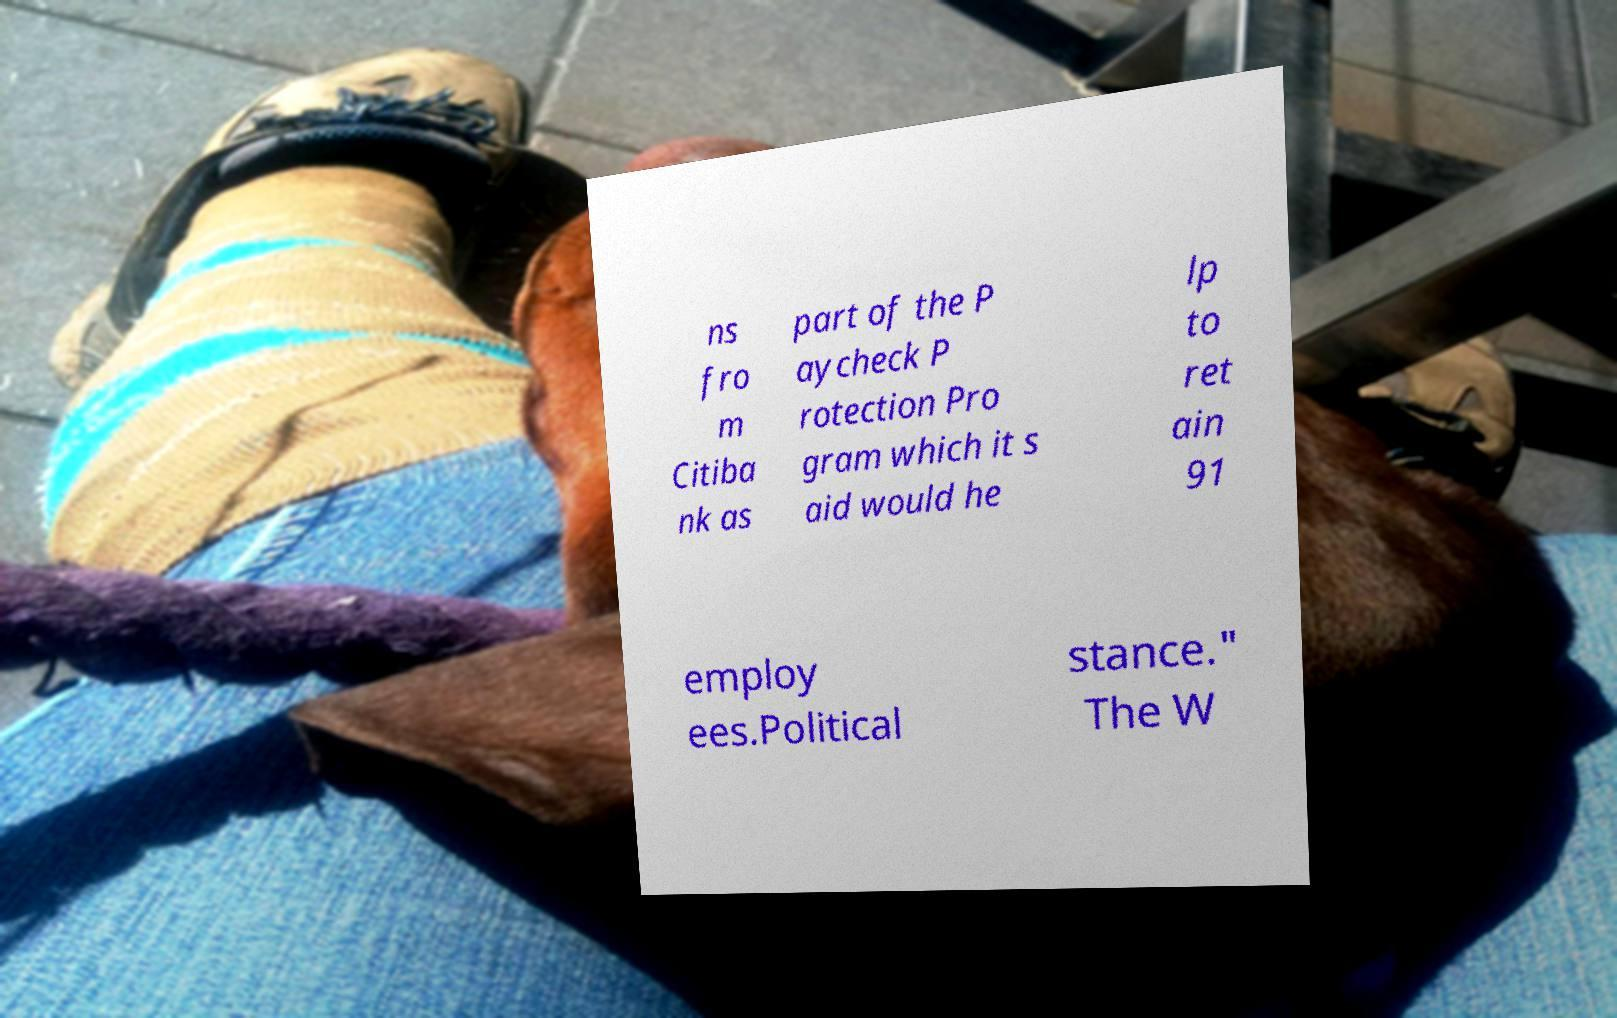What messages or text are displayed in this image? I need them in a readable, typed format. ns fro m Citiba nk as part of the P aycheck P rotection Pro gram which it s aid would he lp to ret ain 91 employ ees.Political stance." The W 